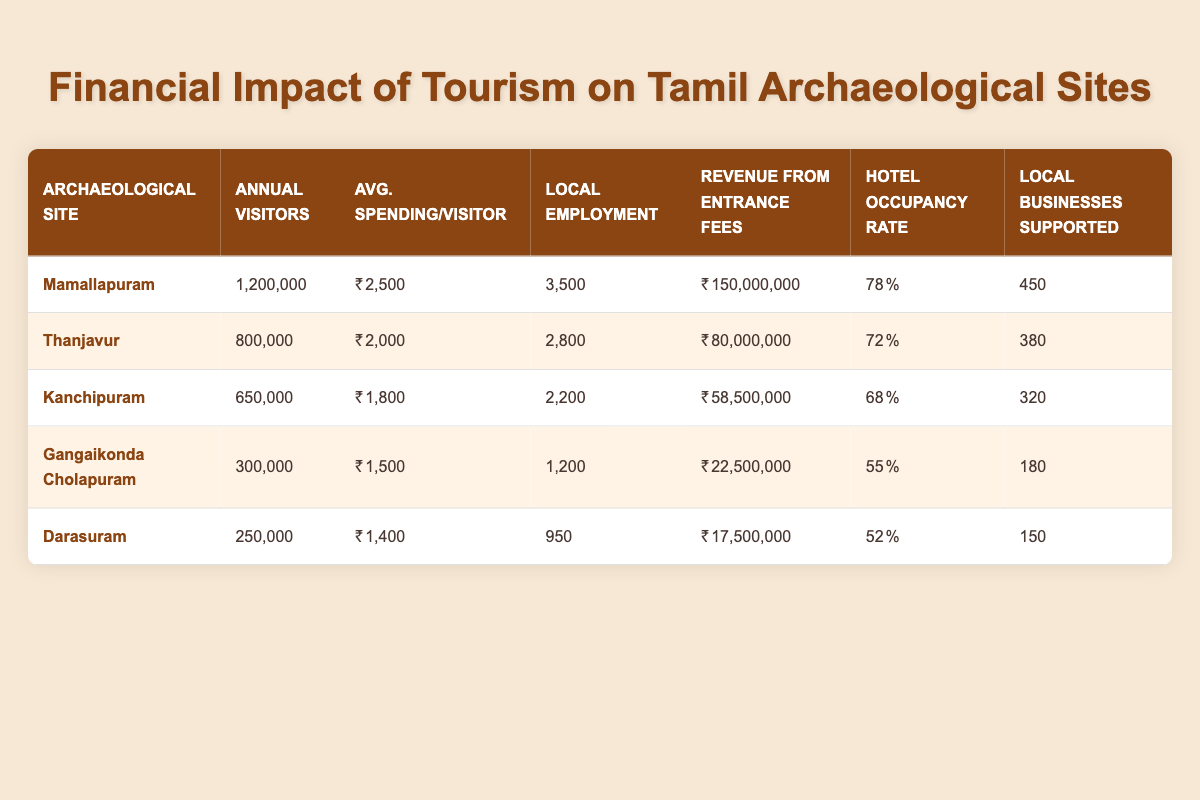What is the average spending per visitor at Mamallapuram? From the table, we see that the average spending per visitor at Mamallapuram is listed as 2500.
Answer: 2500 How many local businesses are supported by tourism in Thanjavur? The number of local businesses supported in Thanjavur is directly stated in the table as 380.
Answer: 380 Which archaeological site has the highest annual visitors? By comparing the annual visitors for each site, Mamallapuram has the highest number at 1,200,000 visitors.
Answer: Mamallapuram What is the total revenue from entrance fees for Gangaikonda Cholapuram and Darasuram combined? The total revenue from entrance fees for Gangaikonda Cholapuram is 22,500,000 and for Darasuram is 17,500,000. Adding these gives 22,500,000 + 17,500,000 = 40,000,000.
Answer: 40000000 Is the hotel occupancy rate in Kanchipuram higher than in Gangaikonda Cholapuram? Kanchipuram's hotel occupancy rate is 68% and Gangaikonda Cholapuram's is 55%. Since 68% is higher than 55%, the statement is true.
Answer: Yes Which sites support more than 300 local businesses? Checking the table, Mamallapuram supports 450, Thanjavur supports 380, and Kanchipuram supports 320. Therefore, Mamallapuram, Thanjavur, and Kanchipuram support more than 300 local businesses.
Answer: Mamallapuram, Thanjavur, Kanchipuram What is the average number of local employment created by the sites listed? To find the average, sum the local employment numbers: 3500 + 2800 + 2200 + 1200 + 950 = 11550. There are 5 sites, so the average is 11550 / 5 = 2310.
Answer: 2310 Does the average spending per visitor decline or increase from Mamallapuram to Darasuram? The average spending decreases as you go from Mamallapuram (2500) to Thanjavur (2000), Kanchipuram (1800), Gangaikonda Cholapuram (1500), and finally Darasuram (1400). Thus, it declines.
Answer: Decline Which site has the lowest revenue from entrance fees? Looking at the revenues, Darasuram has the lowest with 17,500,000 as compared to the others that have higher values.
Answer: Darasuram 